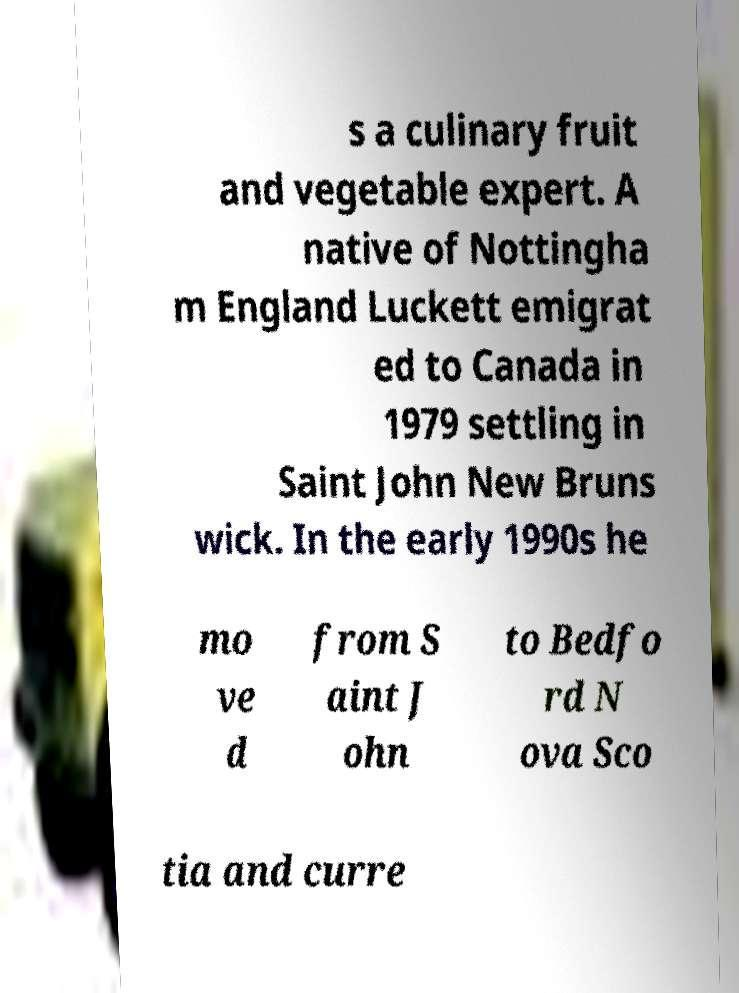There's text embedded in this image that I need extracted. Can you transcribe it verbatim? s a culinary fruit and vegetable expert. A native of Nottingha m England Luckett emigrat ed to Canada in 1979 settling in Saint John New Bruns wick. In the early 1990s he mo ve d from S aint J ohn to Bedfo rd N ova Sco tia and curre 